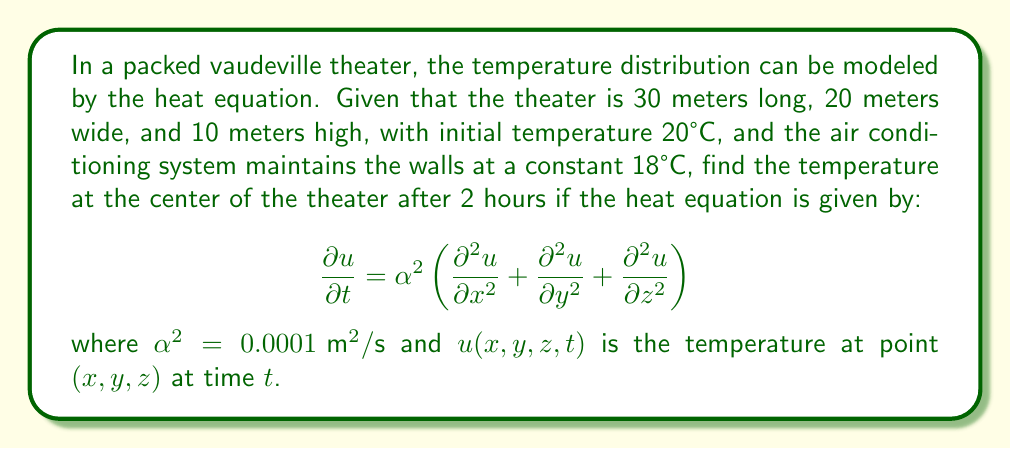What is the answer to this math problem? Let's approach this step-by-step, as if we're choreographing a vaudeville routine:

1) First, we need to set up our boundary conditions. The walls are maintained at 18°C, so:
   $u(0,y,z,t) = u(30,y,z,t) = u(x,0,z,t) = u(x,20,z,t) = u(x,y,0,t) = u(x,y,10,t) = 18$

2) The initial condition is $u(x,y,z,0) = 20$ for all points inside the theater.

3) The solution to this 3D heat equation with these conditions is:

   $$u(x,y,z,t) = 18 + \sum_{l=1}^{\infty}\sum_{m=1}^{\infty}\sum_{n=1}^{\infty} A_{lmn} \sin(\frac{l\pi x}{30}) \sin(\frac{m\pi y}{20}) \sin(\frac{n\pi z}{10}) e^{-\alpha^2(\frac{l^2\pi^2}{900}+\frac{m^2\pi^2}{400}+\frac{n^2\pi^2}{100})t}$$

   where $A_{lmn} = \frac{8}{30 \cdot 20 \cdot 10} \int_0^{30}\int_0^{20}\int_0^{10} 2 \sin(\frac{l\pi x}{30}) \sin(\frac{m\pi y}{20}) \sin(\frac{n\pi z}{10}) dxdydz$

4) Evaluating this integral:
   $A_{lmn} = \frac{64}{\pi^3lmn}$ when $l$, $m$, and $n$ are all odd, and 0 otherwise.

5) At the center of the theater, $(x,y,z) = (15,10,5)$, and after 2 hours, $t = 7200$ seconds.

6) Substituting these values and using only the first term of the series (as higher terms decay much faster):

   $$u(15,10,5,7200) \approx 18 + \frac{64}{\pi^3} \sin(\frac{\pi}{2}) \sin(\frac{\pi}{2}) \sin(\frac{\pi}{2}) e^{-0.0001(\frac{\pi^2}{900}+\frac{\pi^2}{400}+\frac{\pi^2}{100})7200}$$

7) Calculating this:
   $$u(15,10,5,7200) \approx 18 + 2.0 \cdot e^{-0.0563} \approx 19.89°C$$
Answer: 19.89°C 